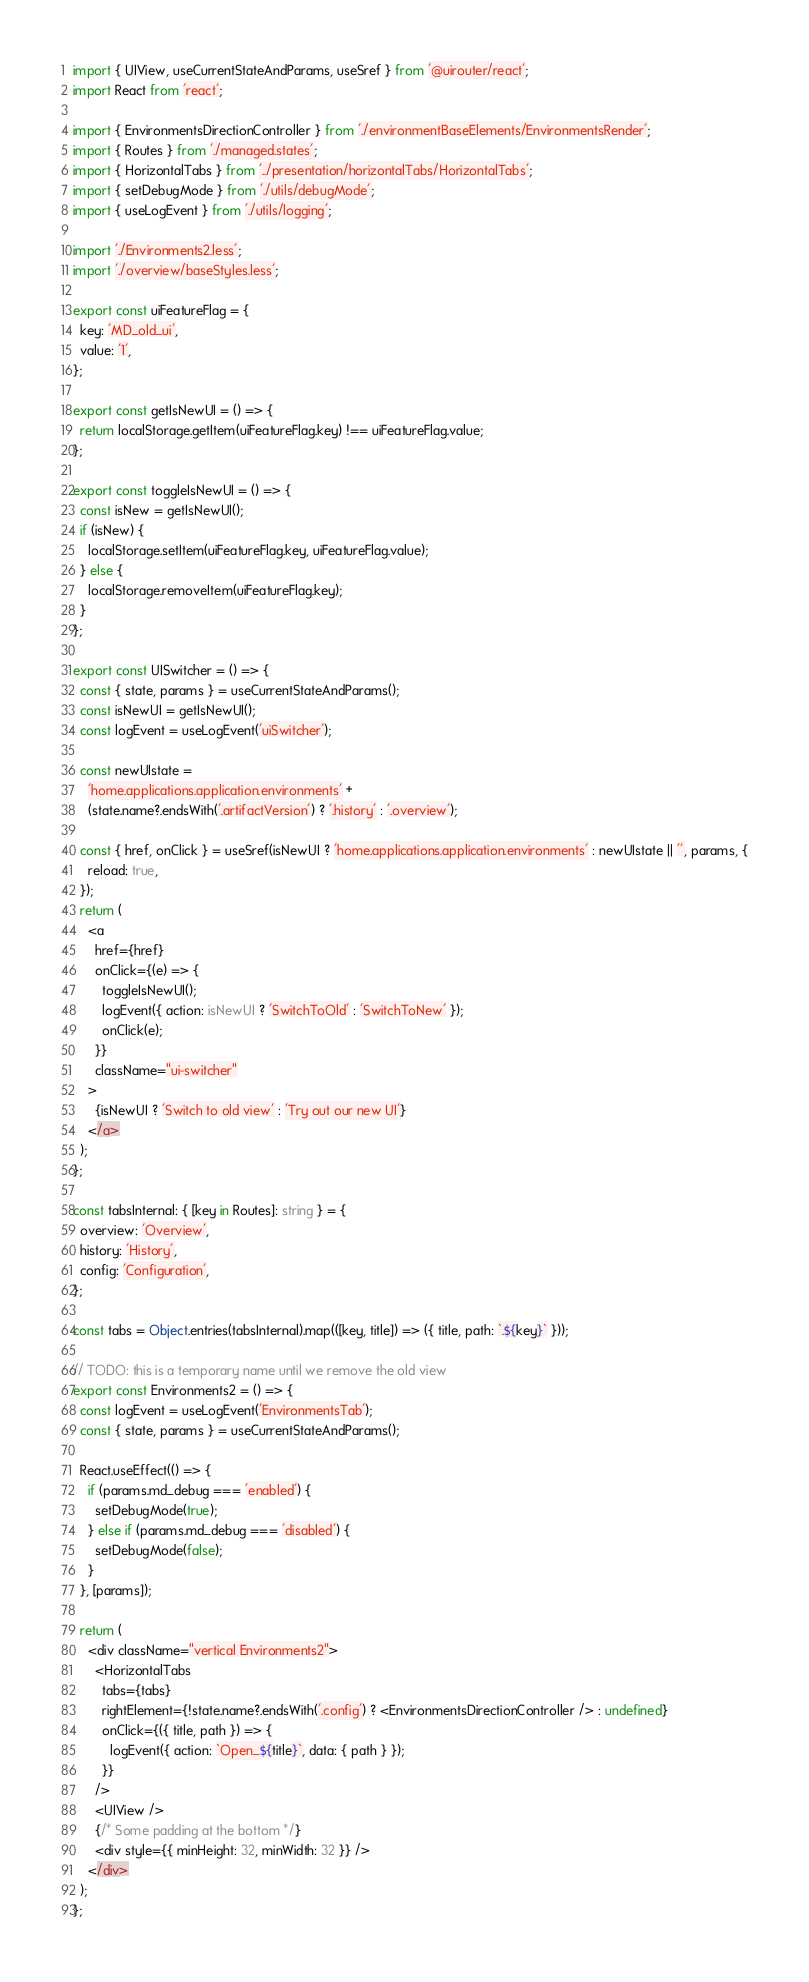Convert code to text. <code><loc_0><loc_0><loc_500><loc_500><_TypeScript_>import { UIView, useCurrentStateAndParams, useSref } from '@uirouter/react';
import React from 'react';

import { EnvironmentsDirectionController } from './environmentBaseElements/EnvironmentsRender';
import { Routes } from './managed.states';
import { HorizontalTabs } from '../presentation/horizontalTabs/HorizontalTabs';
import { setDebugMode } from './utils/debugMode';
import { useLogEvent } from './utils/logging';

import './Environments2.less';
import './overview/baseStyles.less';

export const uiFeatureFlag = {
  key: 'MD_old_ui',
  value: '1',
};

export const getIsNewUI = () => {
  return localStorage.getItem(uiFeatureFlag.key) !== uiFeatureFlag.value;
};

export const toggleIsNewUI = () => {
  const isNew = getIsNewUI();
  if (isNew) {
    localStorage.setItem(uiFeatureFlag.key, uiFeatureFlag.value);
  } else {
    localStorage.removeItem(uiFeatureFlag.key);
  }
};

export const UISwitcher = () => {
  const { state, params } = useCurrentStateAndParams();
  const isNewUI = getIsNewUI();
  const logEvent = useLogEvent('uiSwitcher');

  const newUIstate =
    'home.applications.application.environments' +
    (state.name?.endsWith('.artifactVersion') ? '.history' : '.overview');

  const { href, onClick } = useSref(isNewUI ? 'home.applications.application.environments' : newUIstate || '', params, {
    reload: true,
  });
  return (
    <a
      href={href}
      onClick={(e) => {
        toggleIsNewUI();
        logEvent({ action: isNewUI ? 'SwitchToOld' : 'SwitchToNew' });
        onClick(e);
      }}
      className="ui-switcher"
    >
      {isNewUI ? 'Switch to old view' : 'Try out our new UI'}
    </a>
  );
};

const tabsInternal: { [key in Routes]: string } = {
  overview: 'Overview',
  history: 'History',
  config: 'Configuration',
};

const tabs = Object.entries(tabsInternal).map(([key, title]) => ({ title, path: `.${key}` }));

// TODO: this is a temporary name until we remove the old view
export const Environments2 = () => {
  const logEvent = useLogEvent('EnvironmentsTab');
  const { state, params } = useCurrentStateAndParams();

  React.useEffect(() => {
    if (params.md_debug === 'enabled') {
      setDebugMode(true);
    } else if (params.md_debug === 'disabled') {
      setDebugMode(false);
    }
  }, [params]);

  return (
    <div className="vertical Environments2">
      <HorizontalTabs
        tabs={tabs}
        rightElement={!state.name?.endsWith('.config') ? <EnvironmentsDirectionController /> : undefined}
        onClick={({ title, path }) => {
          logEvent({ action: `Open_${title}`, data: { path } });
        }}
      />
      <UIView />
      {/* Some padding at the bottom */}
      <div style={{ minHeight: 32, minWidth: 32 }} />
    </div>
  );
};
</code> 